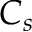Convert formula to latex. <formula><loc_0><loc_0><loc_500><loc_500>C _ { s }</formula> 